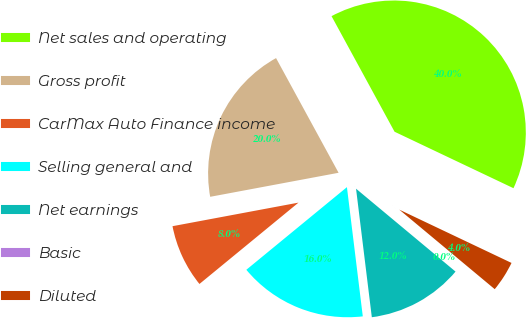<chart> <loc_0><loc_0><loc_500><loc_500><pie_chart><fcel>Net sales and operating<fcel>Gross profit<fcel>CarMax Auto Finance income<fcel>Selling general and<fcel>Net earnings<fcel>Basic<fcel>Diluted<nl><fcel>40.0%<fcel>20.0%<fcel>8.0%<fcel>16.0%<fcel>12.0%<fcel>0.0%<fcel>4.0%<nl></chart> 